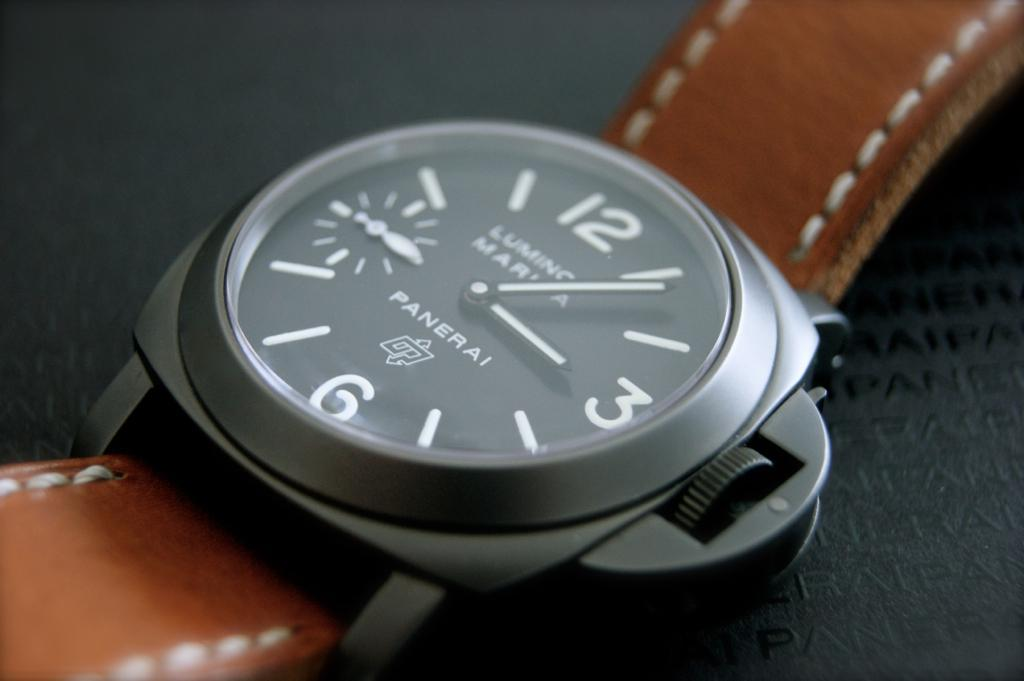What type of accessory is present in the image? There is a wrist watch in the image. What is the frame of the wrist watch made of? The wrist watch has a metallic frame. What material is used for the belts of the wrist watch? The wrist watch has leather belts. What is the color of the leather belts? The leather belts are brown in color. Are there any visible details on the leather belts? Yes, the leather belts have stitches on them. What brand name is visible on the wrist watch? The name "PANERAI" is visible on the watch. Are there any volcanoes visible in the image? No, there are no volcanoes present in the image. Is there a stage in the image where a performance might take place? No, there is no stage present in the image. 